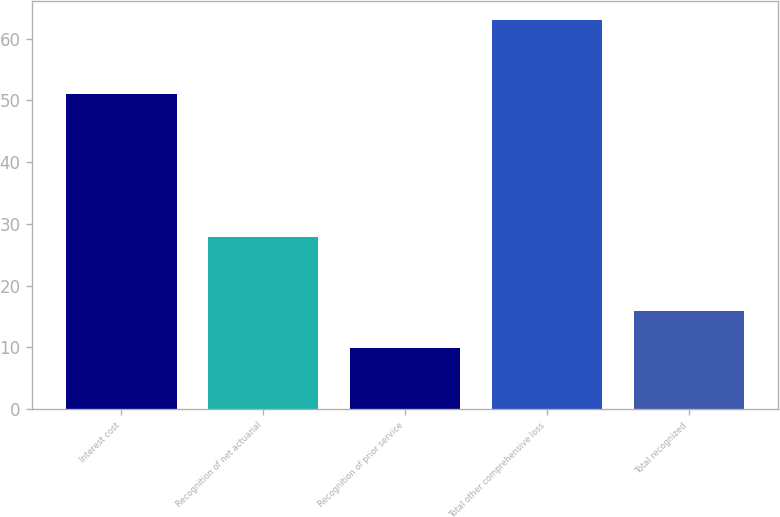<chart> <loc_0><loc_0><loc_500><loc_500><bar_chart><fcel>Interest cost<fcel>Recognition of net actuarial<fcel>Recognition of prior service<fcel>Total other comprehensive loss<fcel>Total recognized<nl><fcel>51<fcel>27.9<fcel>9.9<fcel>63<fcel>15.8<nl></chart> 